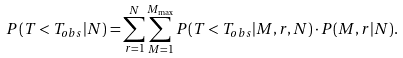Convert formula to latex. <formula><loc_0><loc_0><loc_500><loc_500>P ( T < T _ { o b s } | N ) = \sum _ { r = 1 } ^ { N } \sum _ { M = 1 } ^ { M _ { \max } } P ( T < T _ { o b s } | M , r , N ) \cdot P ( M , r | N ) .</formula> 